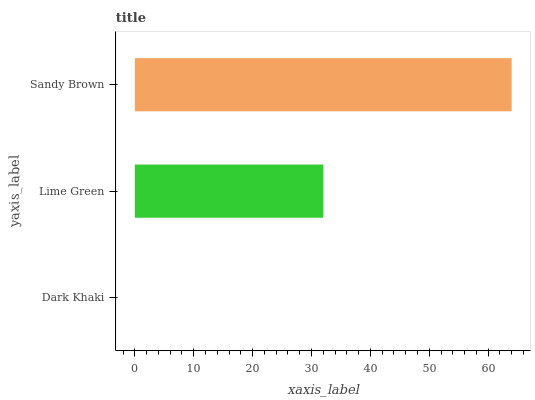Is Dark Khaki the minimum?
Answer yes or no. Yes. Is Sandy Brown the maximum?
Answer yes or no. Yes. Is Lime Green the minimum?
Answer yes or no. No. Is Lime Green the maximum?
Answer yes or no. No. Is Lime Green greater than Dark Khaki?
Answer yes or no. Yes. Is Dark Khaki less than Lime Green?
Answer yes or no. Yes. Is Dark Khaki greater than Lime Green?
Answer yes or no. No. Is Lime Green less than Dark Khaki?
Answer yes or no. No. Is Lime Green the high median?
Answer yes or no. Yes. Is Lime Green the low median?
Answer yes or no. Yes. Is Dark Khaki the high median?
Answer yes or no. No. Is Dark Khaki the low median?
Answer yes or no. No. 